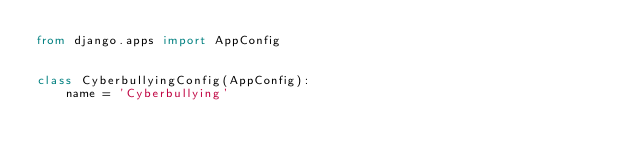<code> <loc_0><loc_0><loc_500><loc_500><_Python_>from django.apps import AppConfig


class CyberbullyingConfig(AppConfig):
    name = 'Cyberbullying'
</code> 